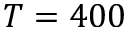<formula> <loc_0><loc_0><loc_500><loc_500>T = 4 0 0</formula> 